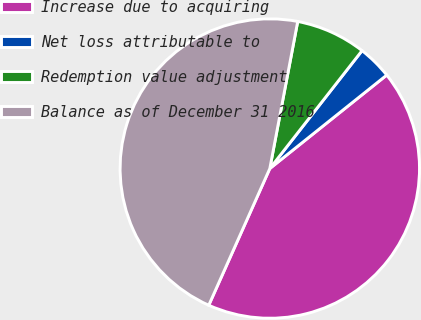Convert chart. <chart><loc_0><loc_0><loc_500><loc_500><pie_chart><fcel>Increase due to acquiring<fcel>Net loss attributable to<fcel>Redemption value adjustment<fcel>Balance as of December 31 2016<nl><fcel>42.42%<fcel>3.7%<fcel>7.58%<fcel>46.3%<nl></chart> 